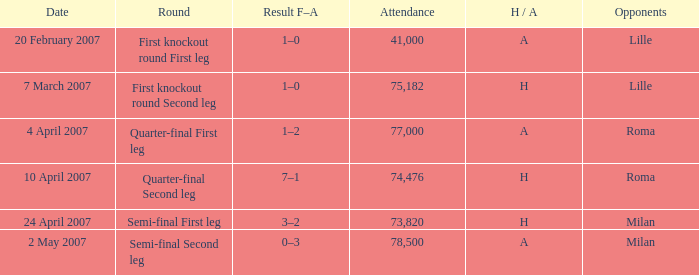Which round has Attendance larger than 41,000, a H/A of A, and a Result F–A of 1–2? Quarter-final First leg. 